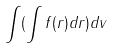Convert formula to latex. <formula><loc_0><loc_0><loc_500><loc_500>\int ( \int f ( r ) d r ) d v</formula> 